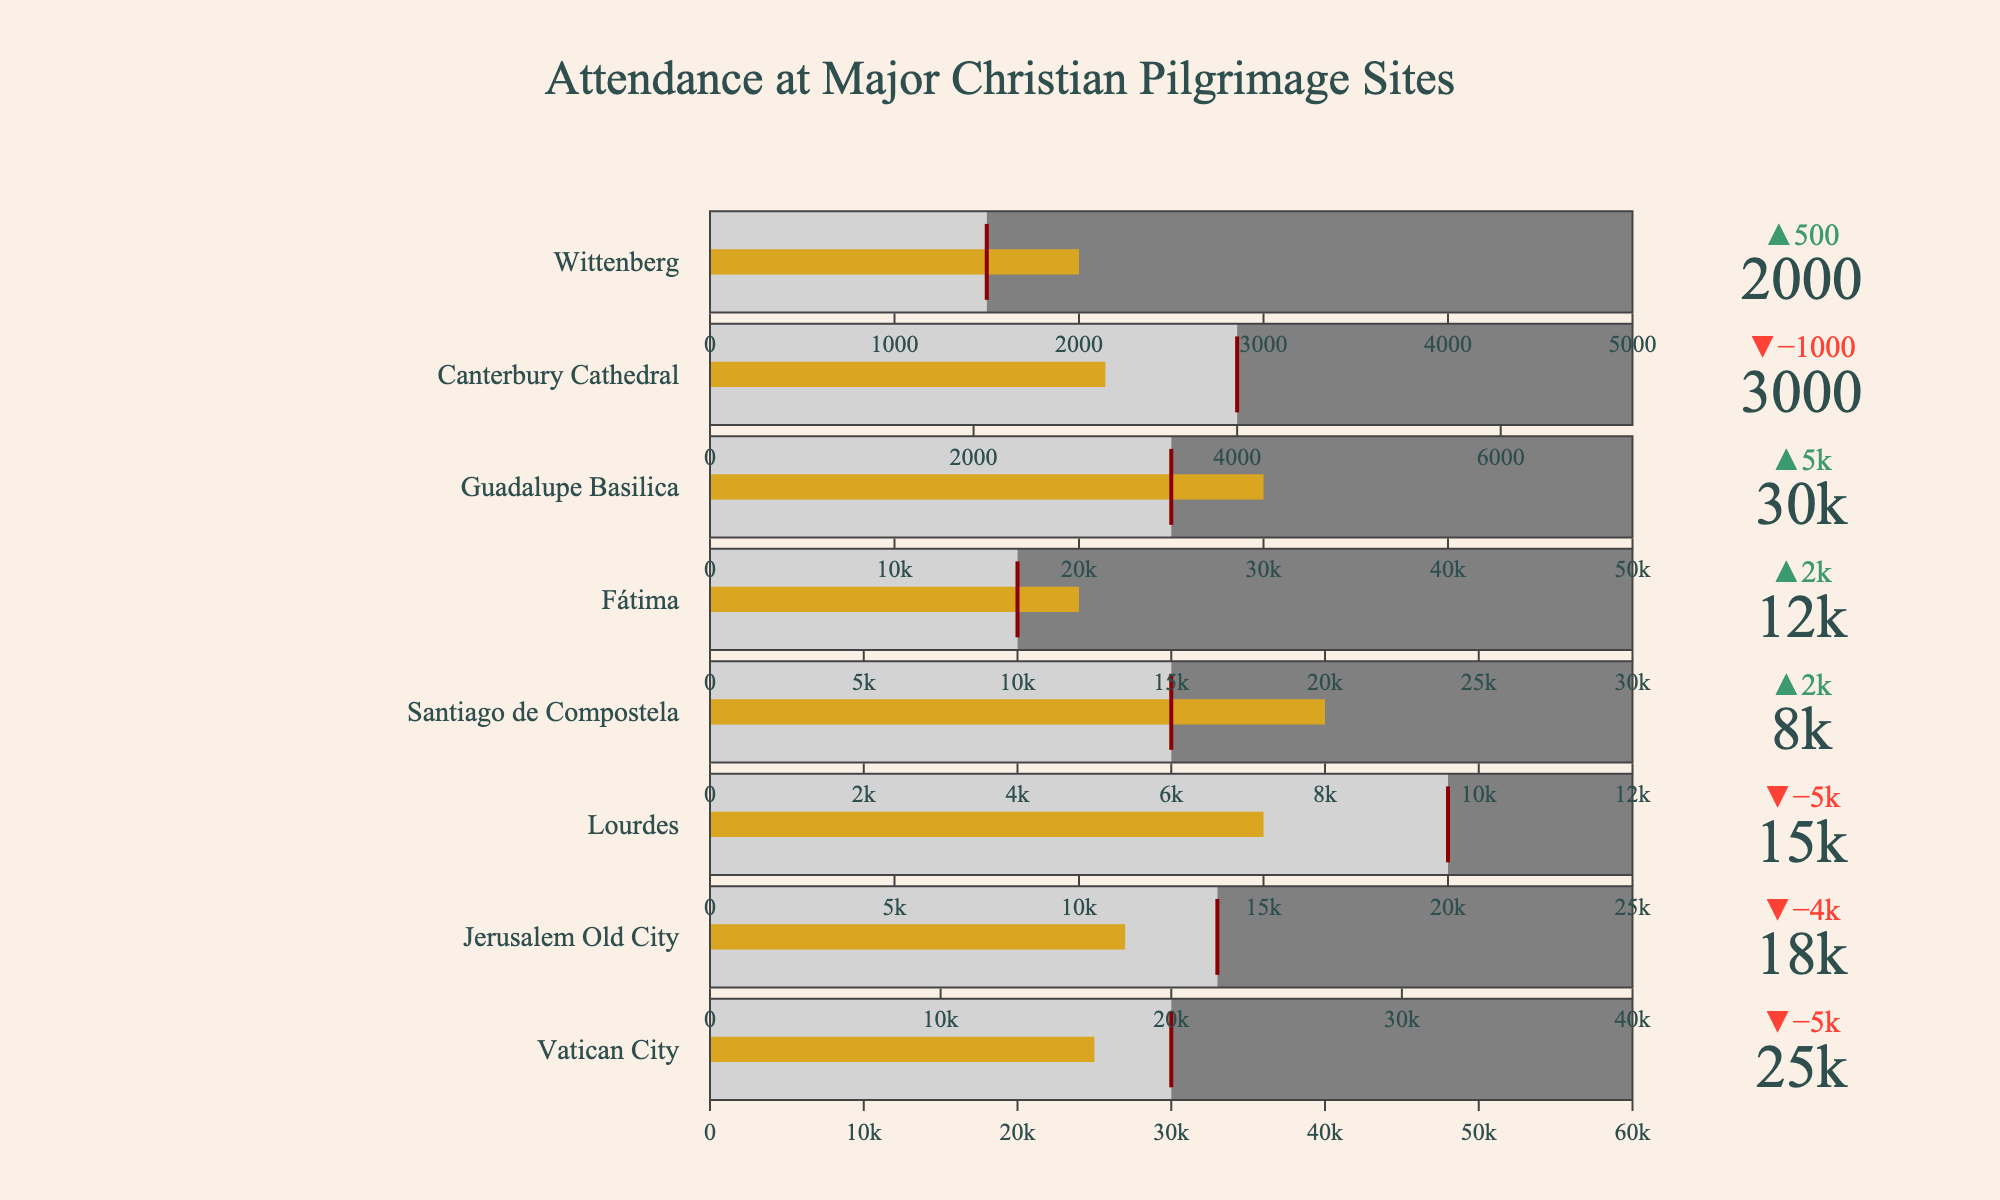What's the current attendance at the Vatican City? The figure shows the "Current Attendance" value for each site. Identify the section for Vatican City and read the attendance number directly.
Answer: 25,000 How does the current attendance at Santiago de Compostela compare to its historical average? Look at the Santiago de Compostela section in the chart. Compare the "Current Attendance" (8,000) with the "Historical Average" (6,000).
Answer: Higher Which site has the greatest difference between current attendance and historical average? Calculate the difference between current attendance and historical average for each site. Vatican City: 25,000 - 30,000 = -5,000; Jerusalem Old City: 18,000 - 22,000 = -4,000; Lourdes: 15,000 - 20,000 = -5,000; Santiago de Compostela: 8,000 - 6,000 = +2,000; Fátima: 12,000 - 10,000 = +2,000; Guadalupe Basilica: 30,000 - 25,000 = +5,000; Canterbury Cathedral: 3,000 - 4,000 = -1,000; Wittenberg: 2,000 - 1,500 = +500. Guadalupe Basilica has the greatest difference.
Answer: Guadalupe Basilica Which site is closest to reaching its capacity limit based on current attendance? For each site, compare the "Current Attendance" to the "Capacity Limit" to see which fraction is the highest. Vatican City: 25,000 / 60,000 ≈ 0.417; Jerusalem Old City: 18,000 / 40,000 = 0.45; Lourdes: 15,000 / 25,000 = 0.6; Santiago de Compostela: 8,000 / 12,000 ≈ 0.666; Fátima: 12,000 / 30,000 = 0.4; Guadalupe Basilica: 30,000 / 50,000 = 0.6; Canterbury Cathedral: 3,000 / 7,000 ≈ 0.429; Wittenberg: 2,000 / 5,000 = 0.4. Santiago de Compostela has the highest ratio.
Answer: Santiago de Compostela What's the overall average current attendance across all sites? Sum the "Current Attendance" values from all sites and divide by the number of sites. (25,000 + 18,000 + 15,000 + 8,000 + 12,000 + 30,000 + 3,000 + 2,000) / 8 = 113,000 / 8 = 14,125
Answer: 14,125 